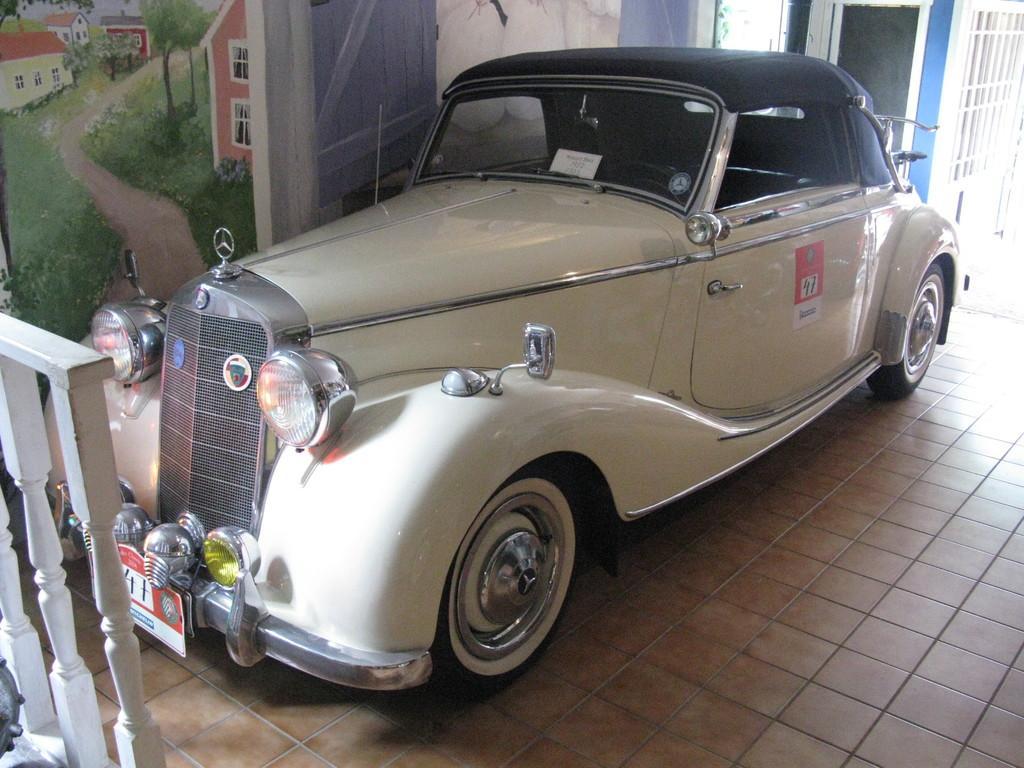How would you summarize this image in a sentence or two? In the center of the image there is a car. On the left we can see a fence. In the background there is a wall painting. At the bottom there is a floor. 